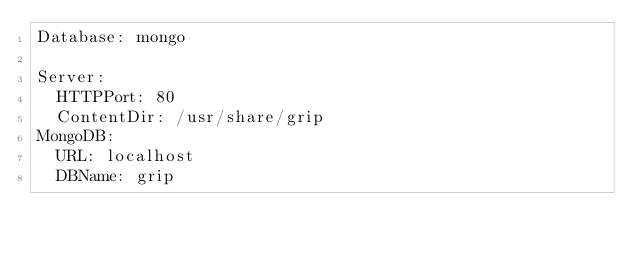<code> <loc_0><loc_0><loc_500><loc_500><_YAML_>Database: mongo

Server:
  HTTPPort: 80
  ContentDir: /usr/share/grip
MongoDB:
  URL: localhost
  DBName: grip
</code> 